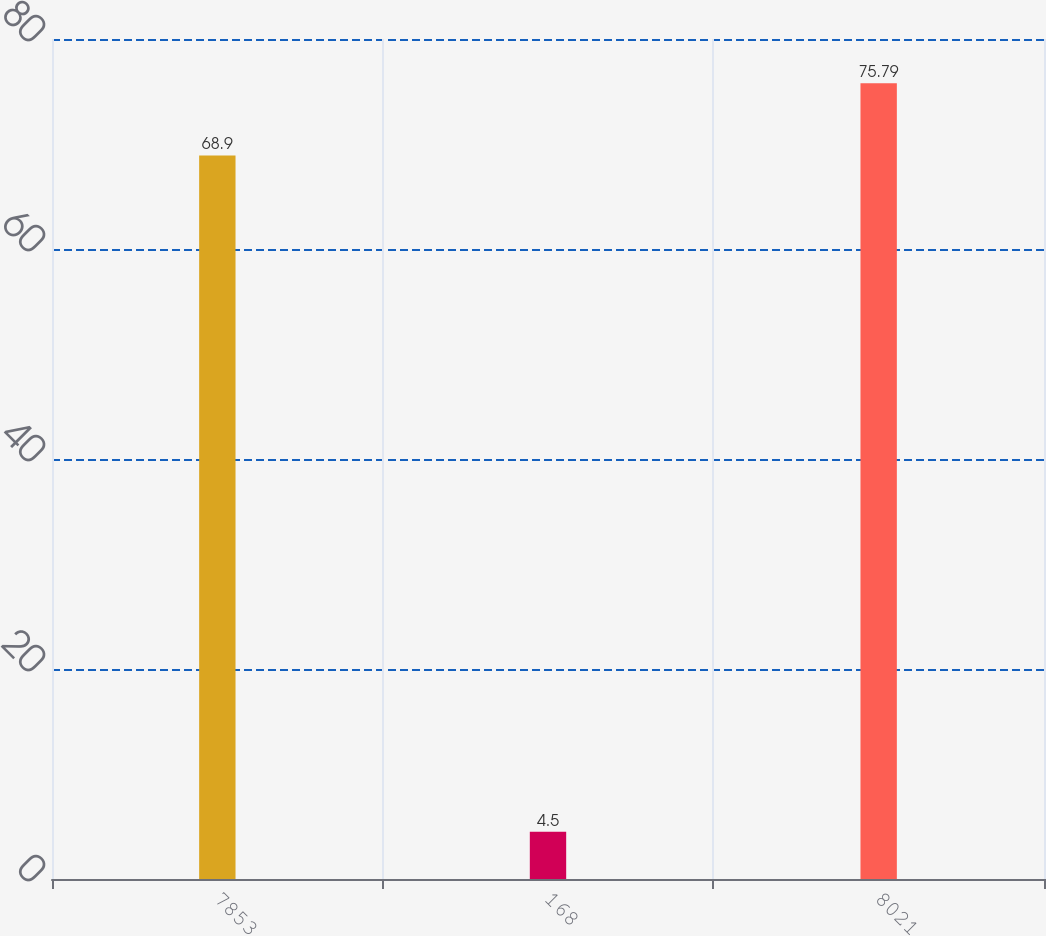<chart> <loc_0><loc_0><loc_500><loc_500><bar_chart><fcel>7853<fcel>168<fcel>8021<nl><fcel>68.9<fcel>4.5<fcel>75.79<nl></chart> 